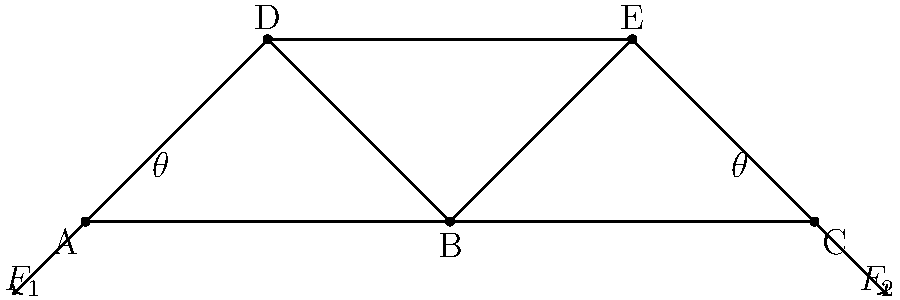Consider the truss bridge structure shown above. If the magnitude of force $F_1$ is 100 kN and the angle $\theta$ is 30°, determine the magnitude of the horizontal component of the force in member BD. Assume the structure is in equilibrium. To solve this problem, we'll follow these steps:

1) First, we need to understand that in a truss, forces act along the members. The force in member BD will have both horizontal and vertical components.

2) Given:
   - $F_1 = 100$ kN
   - $\theta = 30°$

3) The horizontal component of $F_1$ must be balanced by the horizontal components of the forces in members BD and AD for equilibrium.

4) The horizontal component of $F_1$ is:
   $F_{1x} = F_1 \cos \theta = 100 \cos 30° = 100 \cdot \frac{\sqrt{3}}{2} \approx 86.6$ kN

5) Due to symmetry, the horizontal forces in BD and AD will be equal. Let's call the horizontal component of the force in BD as $F_{BD_x}$.

6) For horizontal equilibrium:
   $2F_{BD_x} = F_{1x}$

7) Solving for $F_{BD_x}$:
   $F_{BD_x} = \frac{F_{1x}}{2} = \frac{86.6}{2} = 43.3$ kN

Therefore, the magnitude of the horizontal component of the force in member BD is approximately 43.3 kN.
Answer: 43.3 kN 